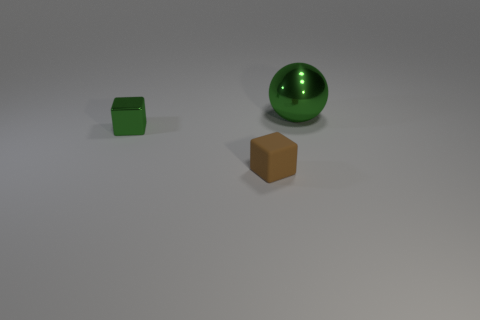Add 3 tiny brown rubber things. How many objects exist? 6 Subtract 1 spheres. How many spheres are left? 0 Subtract all spheres. How many objects are left? 2 Subtract all brown cubes. How many cubes are left? 1 Subtract all gray cubes. Subtract all red cylinders. How many cubes are left? 2 Add 1 small brown rubber cubes. How many small brown rubber cubes are left? 2 Add 1 small green objects. How many small green objects exist? 2 Subtract 0 yellow cylinders. How many objects are left? 3 Subtract all yellow cylinders. How many green cubes are left? 1 Subtract all tiny matte objects. Subtract all big green metallic spheres. How many objects are left? 1 